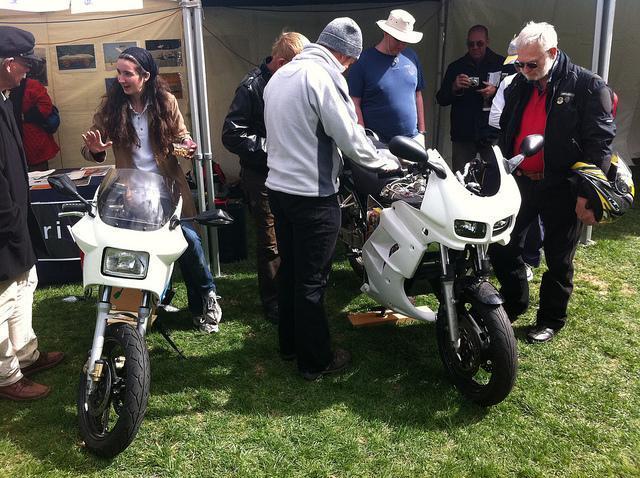How many people are there?
Give a very brief answer. 8. How many motorcycles are there?
Give a very brief answer. 2. 